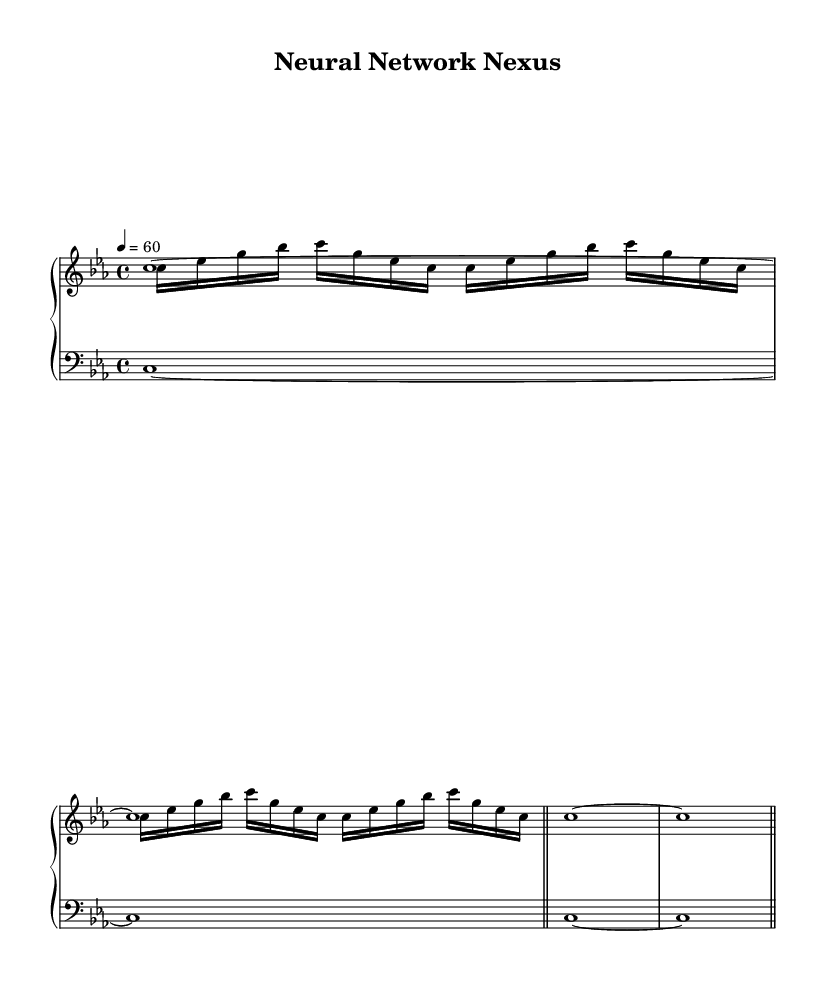What is the key signature of this music? The key signature is indicated by the flat symbols at the beginning of the staff. In this case, it shows B flat and E flat, which corresponds to C minor.
Answer: C minor What is the time signature of this music? The time signature is indicated at the beginning of the staff in the measure, shown as 4 over 4, meaning there are four beats in a measure and a quarter note receives one beat.
Answer: 4/4 What is the tempo marking of this music? The tempo marking is indicated at the beginning of the piece with a metronome marking of 60 beats per minute, which tells the performer to maintain this speed.
Answer: 60 How many voices are used in the upper staff? The upper staff contains two voices as indicated by the two new Voice parts labeled in the score. Each Voice can present its unique melodic line or notes.
Answer: 2 What note duration is primarily used in the bass drone part? The bass drone part consists mainly of whole notes, which are indicated by the notation in the measure, showing long sustained pitches.
Answer: Whole notes How many measures are there in the synth pad part? The synth pad part spans four measures in the score, as indicated by the repeated use of the bar line marking the end of each measure segment.
Answer: 4 What is a unique characteristic of the arpeggiator section? The arpeggiator section contains sixteenth notes organized in a repeating pattern, which is distinct in style and provides a rhythmic texture to the piece.
Answer: Sixteenth notes 